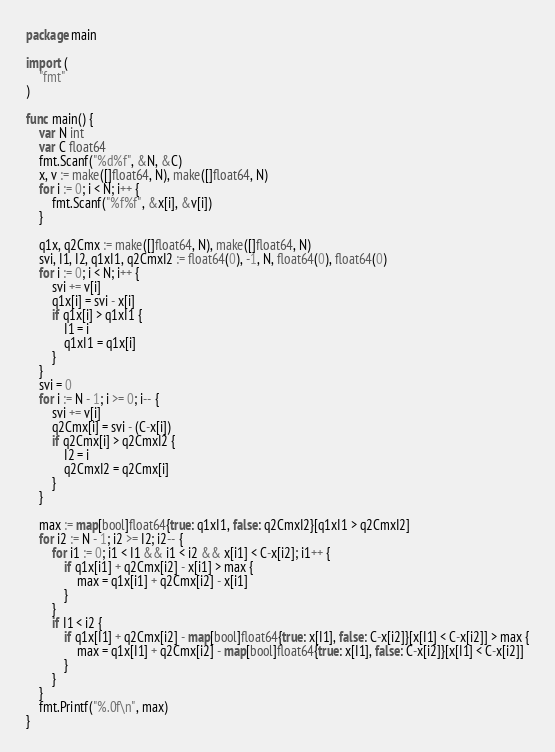<code> <loc_0><loc_0><loc_500><loc_500><_Go_>package main

import (
	"fmt"
)

func main() {
	var N int
	var C float64
	fmt.Scanf("%d%f", &N, &C)
	x, v := make([]float64, N), make([]float64, N)
	for i := 0; i < N; i++ {
		fmt.Scanf("%f%f", &x[i], &v[i])
	}

	q1x, q2Cmx := make([]float64, N), make([]float64, N)
	svi, I1, I2, q1xI1, q2CmxI2 := float64(0), -1, N, float64(0), float64(0)
	for i := 0; i < N; i++ {
		svi += v[i]
		q1x[i] = svi - x[i]
		if q1x[i] > q1xI1 {
			I1 = i
			q1xI1 = q1x[i]
		}
	}
	svi = 0
	for i := N - 1; i >= 0; i-- {
		svi += v[i]
		q2Cmx[i] = svi - (C-x[i])
		if q2Cmx[i] > q2CmxI2 {
			I2 = i
			q2CmxI2 = q2Cmx[i]
		}
	}

	max := map[bool]float64{true: q1xI1, false: q2CmxI2}[q1xI1 > q2CmxI2]
	for i2 := N - 1; i2 >= I2; i2-- {
		for i1 := 0; i1 < I1 && i1 < i2 && x[i1] < C-x[i2]; i1++ {
			if q1x[i1] + q2Cmx[i2] - x[i1] > max {
				max = q1x[i1] + q2Cmx[i2] - x[i1]
			}
		}
		if I1 < i2 {
			if q1x[I1] + q2Cmx[i2] - map[bool]float64{true: x[I1], false: C-x[i2]}[x[I1] < C-x[i2]] > max {
				max = q1x[I1] + q2Cmx[i2] - map[bool]float64{true: x[I1], false: C-x[i2]}[x[I1] < C-x[i2]]
			}
		}
	}
	fmt.Printf("%.0f\n", max)
}

</code> 